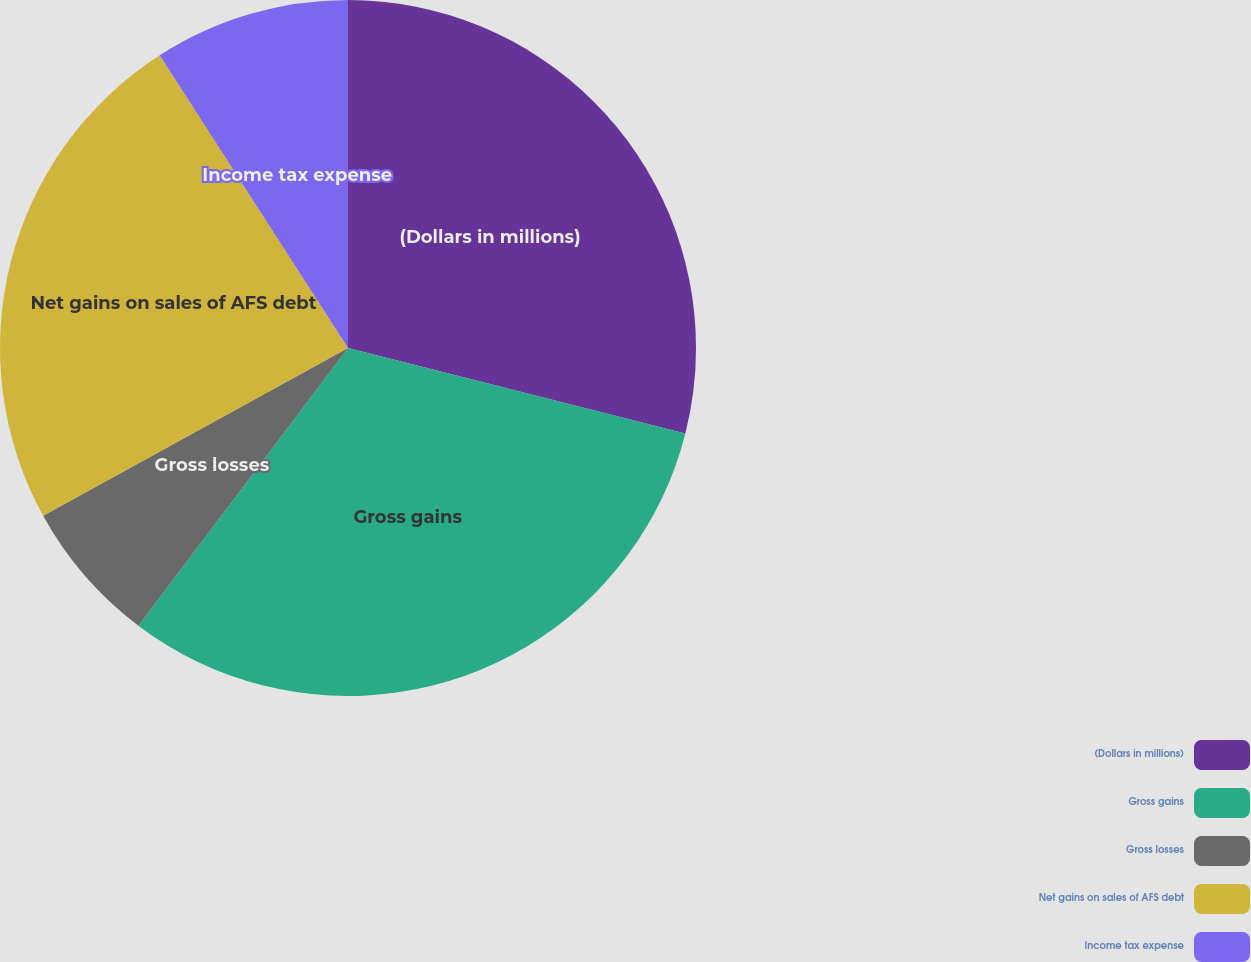<chart> <loc_0><loc_0><loc_500><loc_500><pie_chart><fcel>(Dollars in millions)<fcel>Gross gains<fcel>Gross losses<fcel>Net gains on sales of AFS debt<fcel>Income tax expense<nl><fcel>28.95%<fcel>31.34%<fcel>6.7%<fcel>23.91%<fcel>9.1%<nl></chart> 